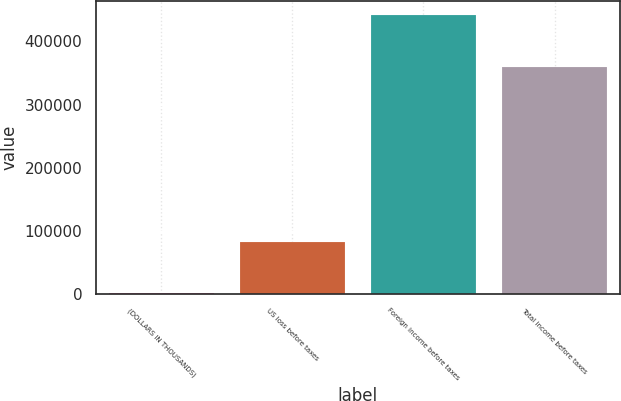<chart> <loc_0><loc_0><loc_500><loc_500><bar_chart><fcel>(DOLLARS IN THOUSANDS)<fcel>US loss before taxes<fcel>Foreign income before taxes<fcel>Total income before taxes<nl><fcel>2010<fcel>82112<fcel>441705<fcel>359593<nl></chart> 